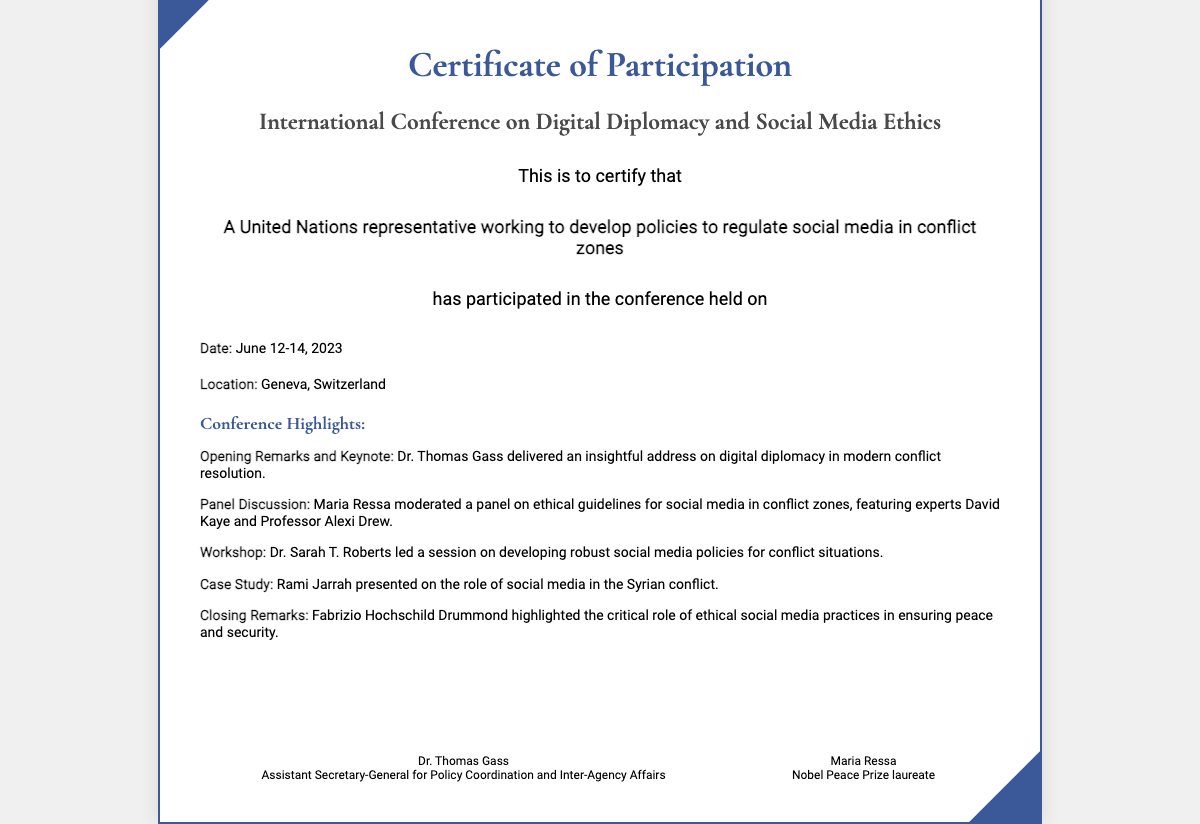What is the title of the conference? The title of the conference is stated clearly in the document.
Answer: International Conference on Digital Diplomacy and Social Media Ethics Who was the keynote speaker? The keynote speaker is mentioned in the conference highlights section.
Answer: Dr. Thomas Gass What were the dates of the conference? The document specifies the dates in the details section.
Answer: June 12-14, 2023 Which location hosted the conference? The location is explicitly detailed in the document.
Answer: Geneva, Switzerland Who moderated the panel on ethical guidelines? The document highlights the moderator of the panel.
Answer: Maria Ressa Name one expert who participated in the panel discussion. The experts are listed in the panel discussion details.
Answer: David Kaye What was a key topic of Dr. Sarah T. Roberts' workshop? The workshop topic is outlined in the summary section.
Answer: Developing robust social media policies What did Rami Jarrah present a case study on? The case study topic is mentioned in the highlights section.
Answer: The role of social media in the Syrian conflict Who provided the closing remarks at the conference? The closing remarks speaker is noted in the conference highlights.
Answer: Fabrizio Hochschild Drummond 